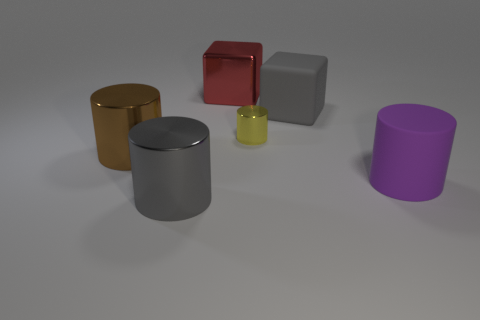Subtract 1 cylinders. How many cylinders are left? 3 Add 4 small cyan balls. How many objects exist? 10 Subtract all blocks. How many objects are left? 4 Add 6 big purple cylinders. How many big purple cylinders exist? 7 Subtract 1 brown cylinders. How many objects are left? 5 Subtract all big shiny objects. Subtract all small gray metallic spheres. How many objects are left? 3 Add 1 large matte things. How many large matte things are left? 3 